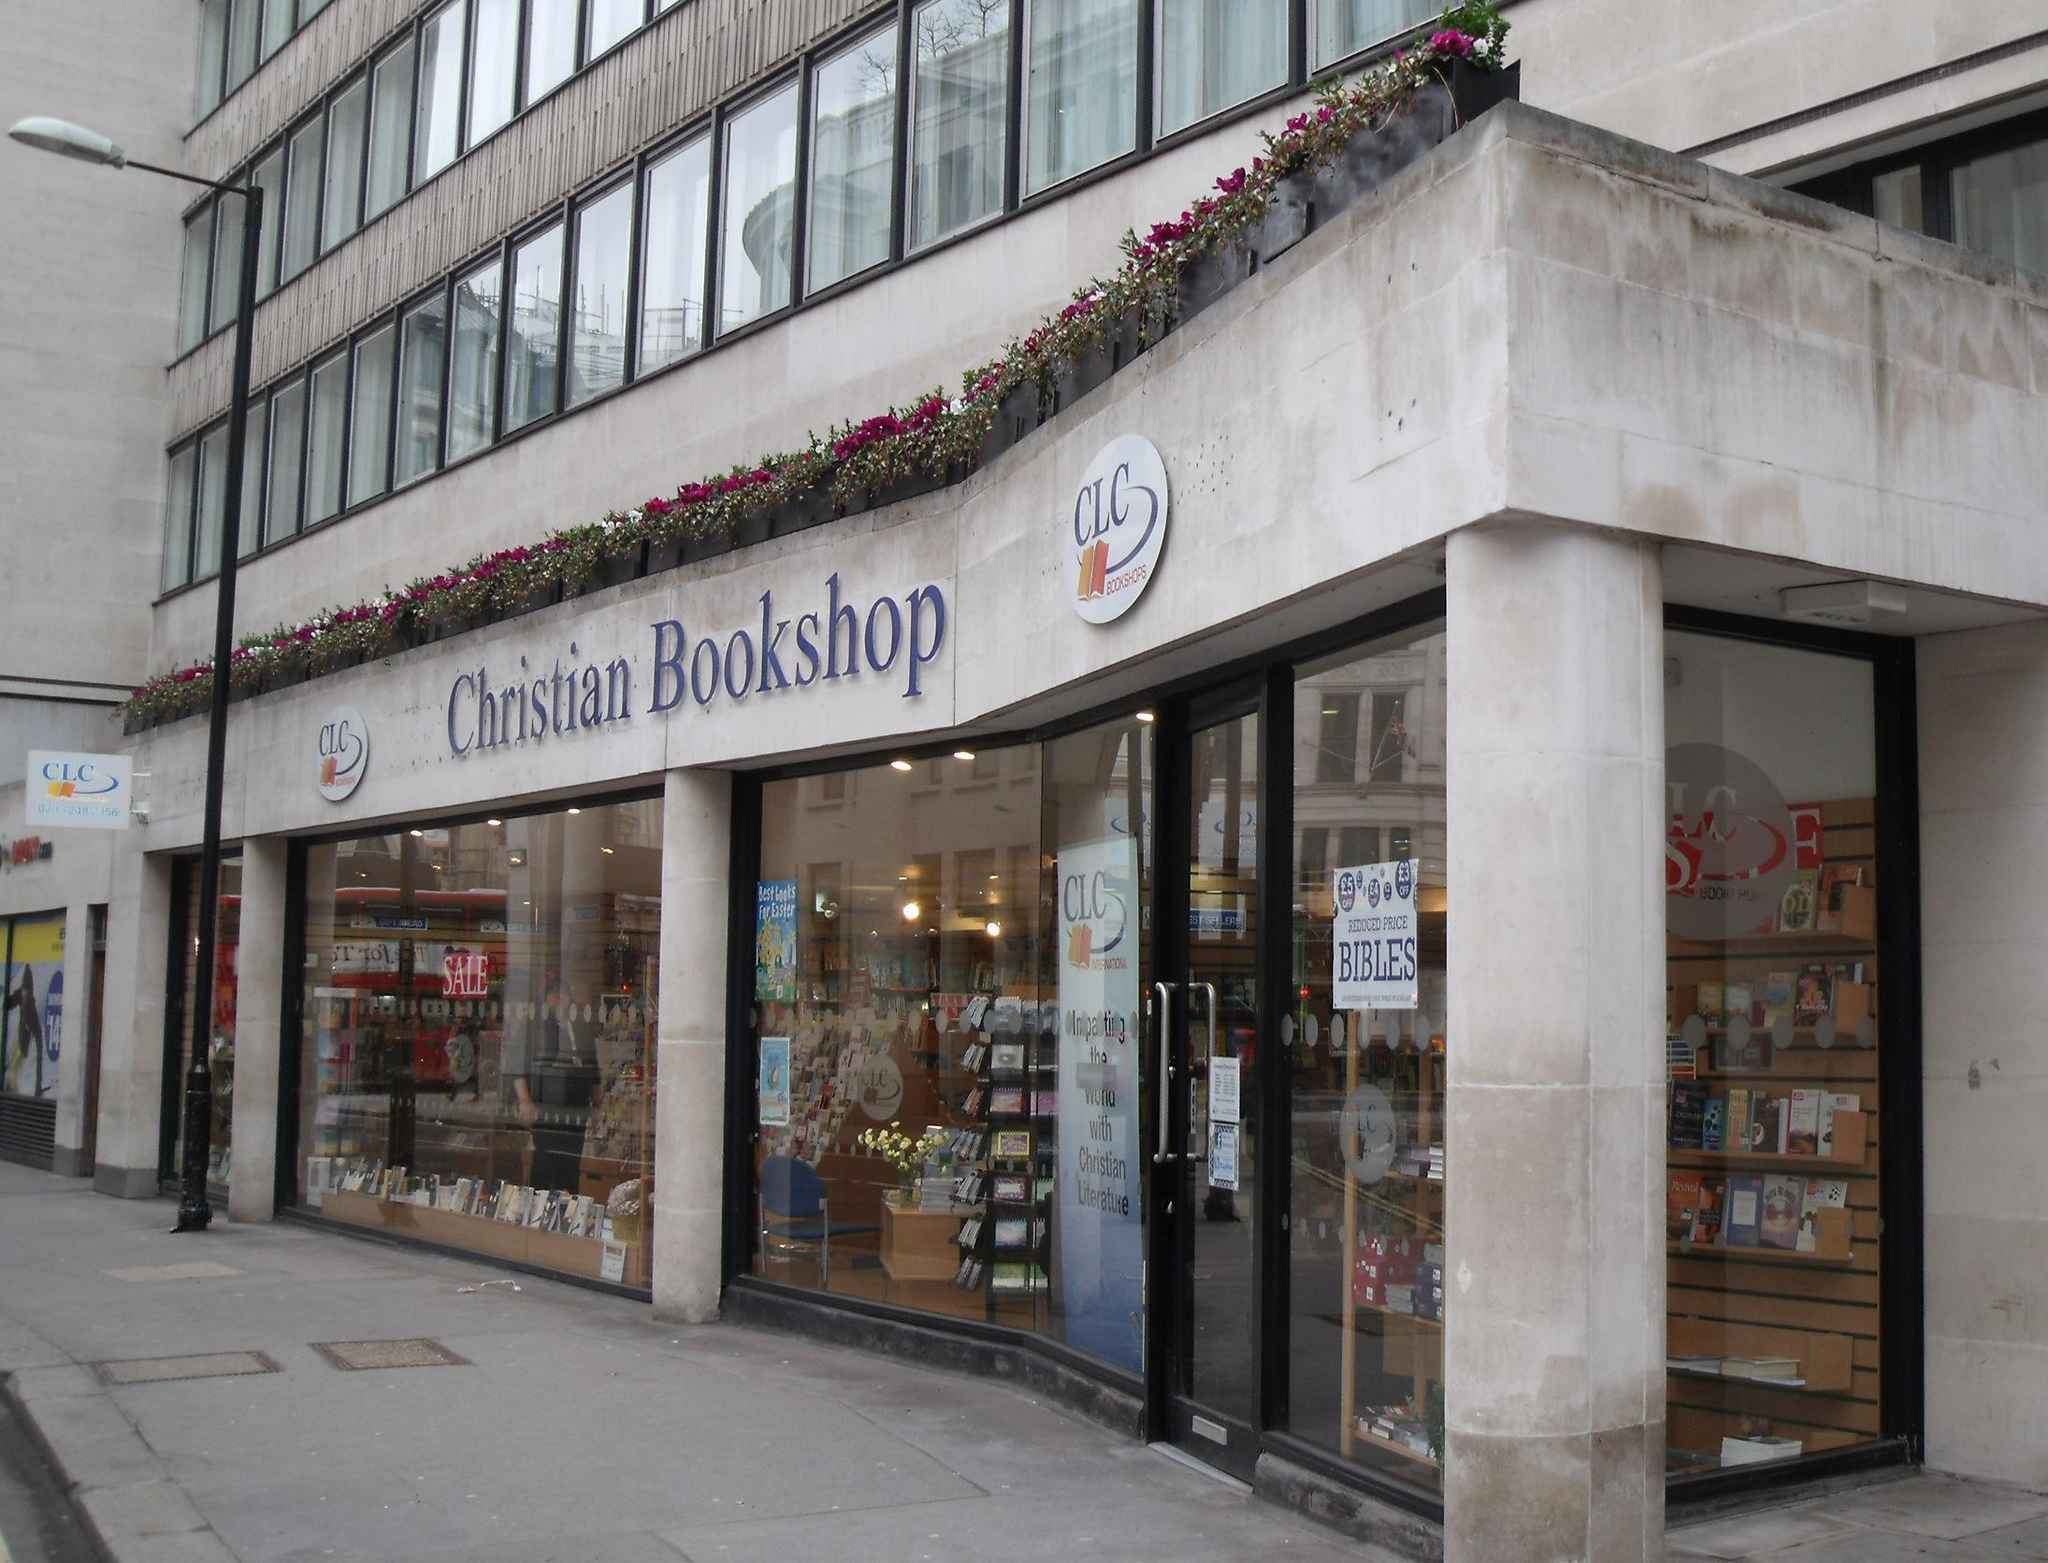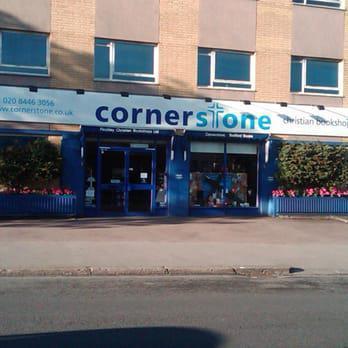The first image is the image on the left, the second image is the image on the right. Analyze the images presented: Is the assertion "The bookstore name is in white with a blue background." valid? Answer yes or no. No. The first image is the image on the left, the second image is the image on the right. Considering the images on both sides, is "The right image shows a bookstore with a blue exterior, a large display window only to the left of one door, and four rectangular panes of glass under its sign." valid? Answer yes or no. No. 